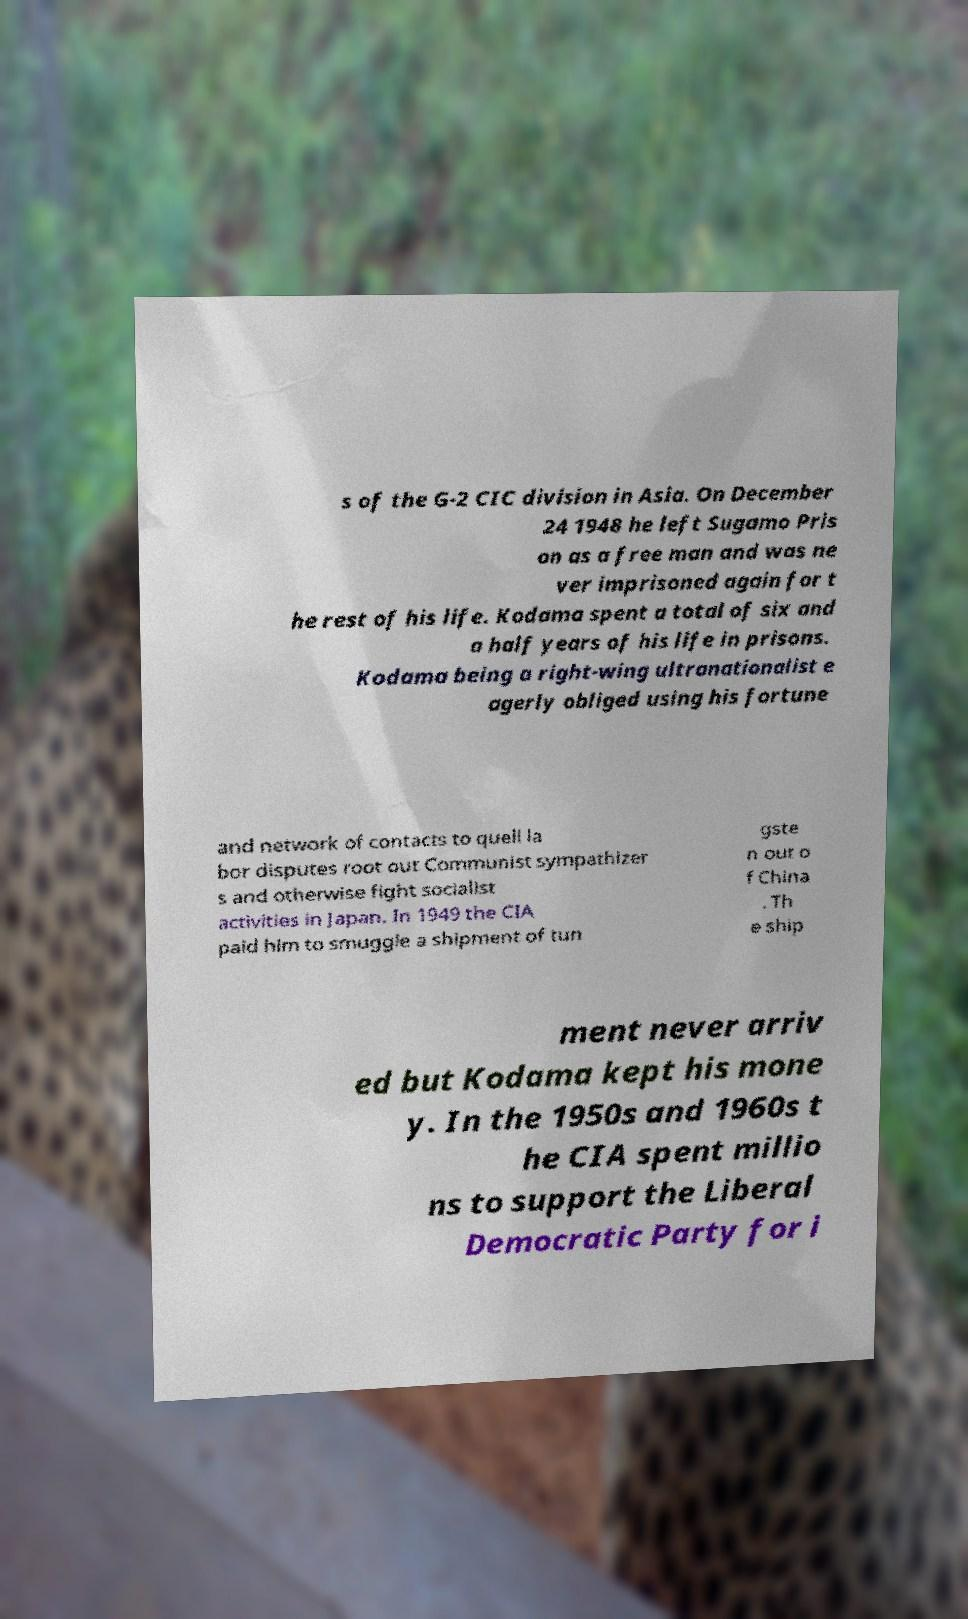I need the written content from this picture converted into text. Can you do that? s of the G-2 CIC division in Asia. On December 24 1948 he left Sugamo Pris on as a free man and was ne ver imprisoned again for t he rest of his life. Kodama spent a total of six and a half years of his life in prisons. Kodama being a right-wing ultranationalist e agerly obliged using his fortune and network of contacts to quell la bor disputes root out Communist sympathizer s and otherwise fight socialist activities in Japan. In 1949 the CIA paid him to smuggle a shipment of tun gste n out o f China . Th e ship ment never arriv ed but Kodama kept his mone y. In the 1950s and 1960s t he CIA spent millio ns to support the Liberal Democratic Party for i 